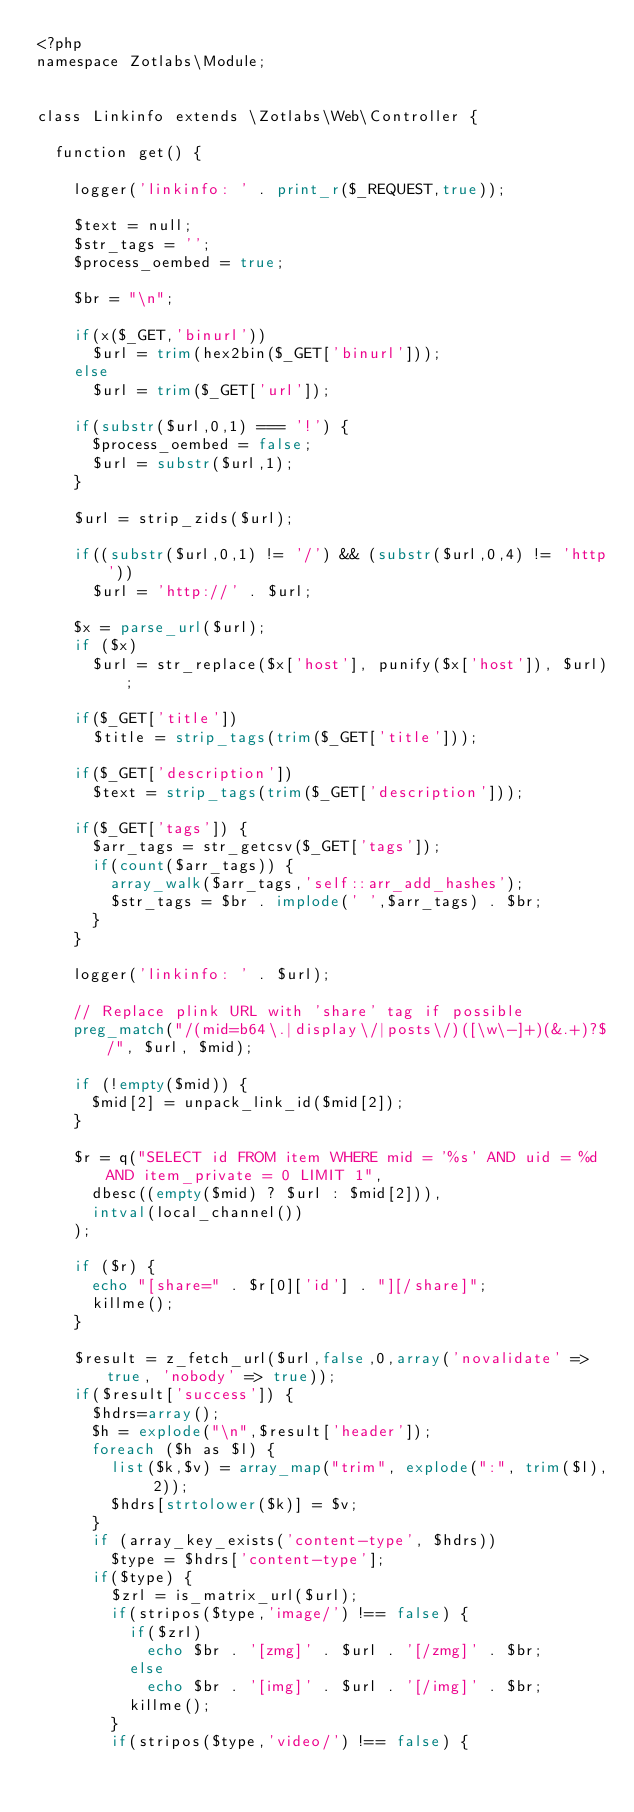Convert code to text. <code><loc_0><loc_0><loc_500><loc_500><_PHP_><?php
namespace Zotlabs\Module;


class Linkinfo extends \Zotlabs\Web\Controller {

	function get() {

		logger('linkinfo: ' . print_r($_REQUEST,true));

		$text = null;
		$str_tags = '';
		$process_oembed = true;

		$br = "\n";

		if(x($_GET,'binurl'))
			$url = trim(hex2bin($_GET['binurl']));
		else
			$url = trim($_GET['url']);

		if(substr($url,0,1) === '!') {
			$process_oembed = false;
			$url = substr($url,1);
		}

		$url = strip_zids($url);

		if((substr($url,0,1) != '/') && (substr($url,0,4) != 'http'))
			$url = 'http://' . $url;

		$x = parse_url($url);
		if ($x)
			$url = str_replace($x['host'], punify($x['host']), $url);

		if($_GET['title'])
			$title = strip_tags(trim($_GET['title']));

		if($_GET['description'])
			$text = strip_tags(trim($_GET['description']));

		if($_GET['tags']) {
			$arr_tags = str_getcsv($_GET['tags']);
			if(count($arr_tags)) {
				array_walk($arr_tags,'self::arr_add_hashes');
				$str_tags = $br . implode(' ',$arr_tags) . $br;
			}
		}

		logger('linkinfo: ' . $url);

		// Replace plink URL with 'share' tag if possible
		preg_match("/(mid=b64\.|display\/|posts\/)([\w\-]+)(&.+)?$/", $url, $mid);

		if (!empty($mid)) {
			$mid[2] = unpack_link_id($mid[2]);
		}

		$r = q("SELECT id FROM item WHERE mid = '%s' AND uid = %d AND item_private = 0 LIMIT 1",
			dbesc((empty($mid) ? $url : $mid[2])),
			intval(local_channel())
		);

		if ($r) {
			echo "[share=" . $r[0]['id'] . "][/share]";
			killme();
		}

		$result = z_fetch_url($url,false,0,array('novalidate' => true, 'nobody' => true));
		if($result['success']) {
			$hdrs=array();
			$h = explode("\n",$result['header']);
			foreach ($h as $l) {
				list($k,$v) = array_map("trim", explode(":", trim($l), 2));
				$hdrs[strtolower($k)] = $v;
			}
			if (array_key_exists('content-type', $hdrs))
				$type = $hdrs['content-type'];
			if($type) {
				$zrl = is_matrix_url($url);
				if(stripos($type,'image/') !== false) {
					if($zrl)
						echo $br . '[zmg]' . $url . '[/zmg]' . $br;
					else
						echo $br . '[img]' . $url . '[/img]' . $br;
					killme();
				}
				if(stripos($type,'video/') !== false) {</code> 